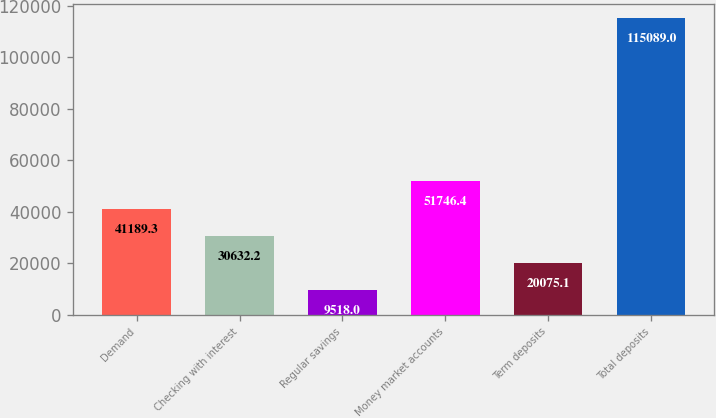<chart> <loc_0><loc_0><loc_500><loc_500><bar_chart><fcel>Demand<fcel>Checking with interest<fcel>Regular savings<fcel>Money market accounts<fcel>Term deposits<fcel>Total deposits<nl><fcel>41189.3<fcel>30632.2<fcel>9518<fcel>51746.4<fcel>20075.1<fcel>115089<nl></chart> 